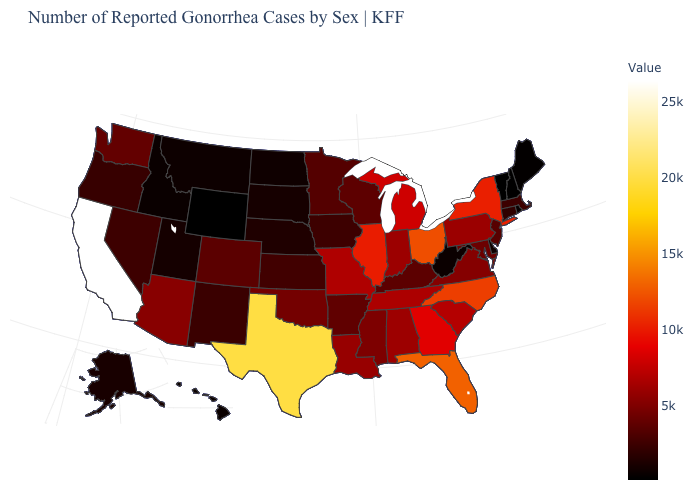Which states have the highest value in the USA?
Quick response, please. California. Does the map have missing data?
Keep it brief. No. Does Minnesota have a lower value than Idaho?
Keep it brief. No. Does California have the highest value in the West?
Quick response, please. Yes. Which states have the lowest value in the MidWest?
Concise answer only. North Dakota. Which states have the highest value in the USA?
Be succinct. California. Among the states that border Massachusetts , does New York have the highest value?
Quick response, please. Yes. 